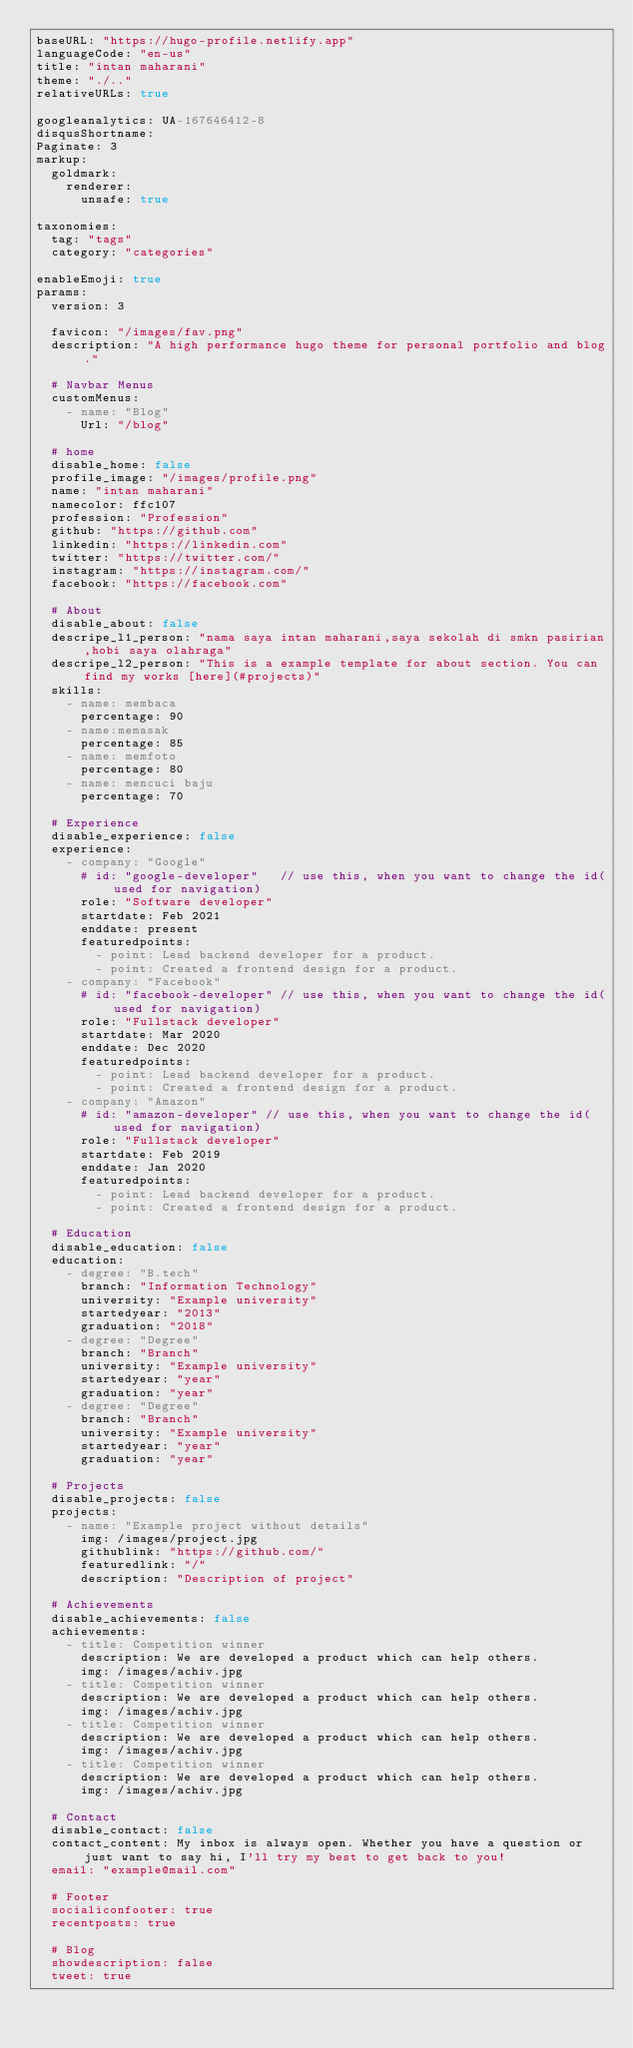Convert code to text. <code><loc_0><loc_0><loc_500><loc_500><_YAML_>baseURL: "https://hugo-profile.netlify.app"
languageCode: "en-us"
title: "intan maharani"
theme: "./.."
relativeURLs: true

googleanalytics: UA-167646412-8
disqusShortname:
Paginate: 3
markup:
  goldmark:
    renderer:
      unsafe: true

taxonomies:
  tag: "tags"
  category: "categories"

enableEmoji: true
params:
  version: 3

  favicon: "/images/fav.png"
  description: "A high performance hugo theme for personal portfolio and blog."

  # Navbar Menus
  customMenus:
    - name: "Blog"
      Url: "/blog"

  # home
  disable_home: false
  profile_image: "/images/profile.png"
  name: "intan maharani"
  namecolor: ffc107
  profession: "Profession"
  github: "https://github.com"
  linkedin: "https://linkedin.com"
  twitter: "https://twitter.com/"
  instagram: "https://instagram.com/"
  facebook: "https://facebook.com"

  # About
  disable_about: false
  descripe_l1_person: "nama saya intan maharani,saya sekolah di smkn pasirian,hobi saya olahraga"
  descripe_l2_person: "This is a example template for about section. You can find my works [here](#projects)"
  skills:
    - name: membaca
      percentage: 90
    - name:memasak
      percentage: 85
    - name: memfoto
      percentage: 80
    - name: mencuci baju
      percentage: 70

  # Experience
  disable_experience: false
  experience:
    - company: "Google"
      # id: "google-developer"   // use this, when you want to change the id(used for navigation)
      role: "Software developer"
      startdate: Feb 2021
      enddate: present
      featuredpoints:
        - point: Lead backend developer for a product.
        - point: Created a frontend design for a product.
    - company: "Facebook"
      # id: "facebook-developer" // use this, when you want to change the id(used for navigation)
      role: "Fullstack developer"
      startdate: Mar 2020
      enddate: Dec 2020
      featuredpoints:
        - point: Lead backend developer for a product.
        - point: Created a frontend design for a product.
    - company: "Amazon"
      # id: "amazon-developer" // use this, when you want to change the id(used for navigation)
      role: "Fullstack developer"
      startdate: Feb 2019
      enddate: Jan 2020
      featuredpoints:
        - point: Lead backend developer for a product.
        - point: Created a frontend design for a product.

  # Education
  disable_education: false
  education:
    - degree: "B.tech"
      branch: "Information Technology"
      university: "Example university"
      startedyear: "2013"
      graduation: "2018"
    - degree: "Degree"
      branch: "Branch"
      university: "Example university"
      startedyear: "year"
      graduation: "year"
    - degree: "Degree"
      branch: "Branch"
      university: "Example university"
      startedyear: "year"
      graduation: "year"

  # Projects
  disable_projects: false
  projects:
    - name: "Example project without details"
      img: /images/project.jpg
      githublink: "https://github.com/"
      featuredlink: "/"
      description: "Description of project"

  # Achievements
  disable_achievements: false
  achievements:
    - title: Competition winner
      description: We are developed a product which can help others.
      img: /images/achiv.jpg
    - title: Competition winner
      description: We are developed a product which can help others.
      img: /images/achiv.jpg
    - title: Competition winner
      description: We are developed a product which can help others.
      img: /images/achiv.jpg
    - title: Competition winner
      description: We are developed a product which can help others.
      img: /images/achiv.jpg

  # Contact
  disable_contact: false
  contact_content: My inbox is always open. Whether you have a question or just want to say hi, I'll try my best to get back to you!
  email: "example@mail.com"

  # Footer
  socialiconfooter: true
  recentposts: true

  # Blog
  showdescription: false
  tweet: true
</code> 